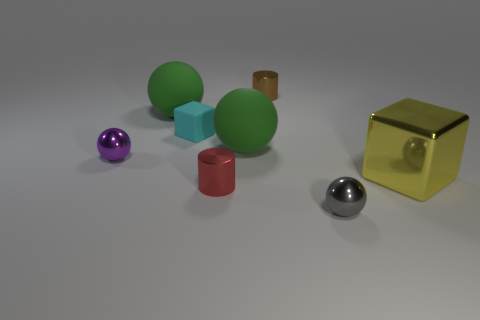Subtract all gray cylinders. Subtract all brown spheres. How many cylinders are left? 2 Add 1 small blue cylinders. How many objects exist? 9 Subtract all cubes. How many objects are left? 6 Add 7 yellow metal objects. How many yellow metal objects exist? 8 Subtract 0 purple blocks. How many objects are left? 8 Subtract all balls. Subtract all tiny gray spheres. How many objects are left? 3 Add 2 big shiny cubes. How many big shiny cubes are left? 3 